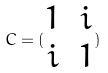<formula> <loc_0><loc_0><loc_500><loc_500>C = ( \begin{matrix} 1 & i \\ i & 1 \end{matrix} )</formula> 